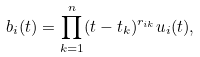<formula> <loc_0><loc_0><loc_500><loc_500>b _ { i } ( t ) = \prod _ { k = 1 } ^ { n } ( t - t _ { k } ) ^ { r _ { i k } } u _ { i } ( t ) ,</formula> 